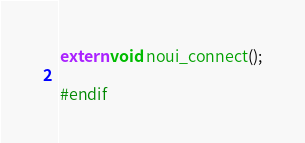Convert code to text. <code><loc_0><loc_0><loc_500><loc_500><_C_>
extern void noui_connect();

#endif
</code> 